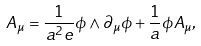<formula> <loc_0><loc_0><loc_500><loc_500>A _ { \mu } = \frac { 1 } { a ^ { 2 } e } \phi \wedge \partial _ { \mu } \phi + \frac { 1 } { a } \phi A _ { \mu } ,</formula> 